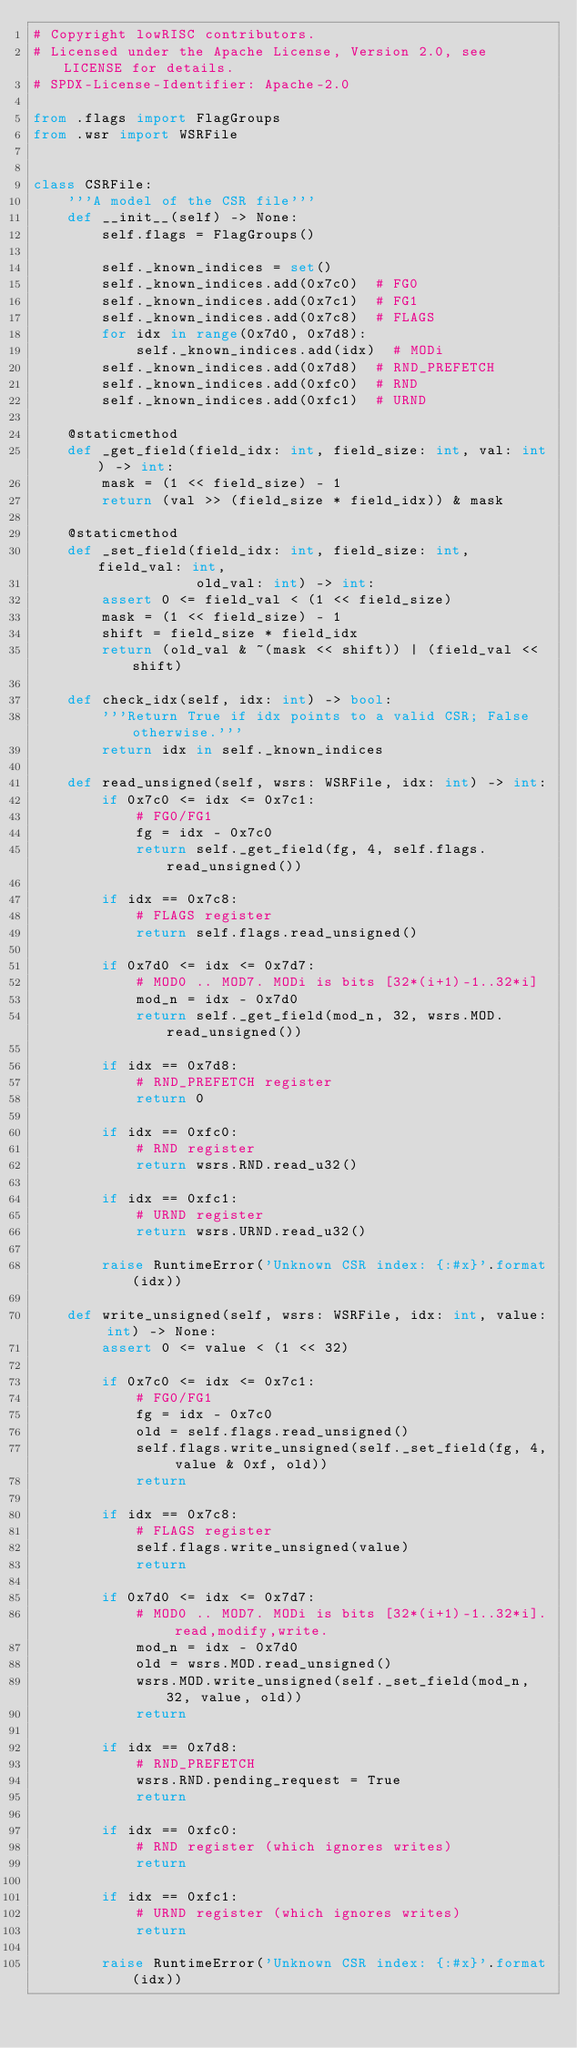Convert code to text. <code><loc_0><loc_0><loc_500><loc_500><_Python_># Copyright lowRISC contributors.
# Licensed under the Apache License, Version 2.0, see LICENSE for details.
# SPDX-License-Identifier: Apache-2.0

from .flags import FlagGroups
from .wsr import WSRFile


class CSRFile:
    '''A model of the CSR file'''
    def __init__(self) -> None:
        self.flags = FlagGroups()

        self._known_indices = set()
        self._known_indices.add(0x7c0)  # FG0
        self._known_indices.add(0x7c1)  # FG1
        self._known_indices.add(0x7c8)  # FLAGS
        for idx in range(0x7d0, 0x7d8):
            self._known_indices.add(idx)  # MODi
        self._known_indices.add(0x7d8)  # RND_PREFETCH
        self._known_indices.add(0xfc0)  # RND
        self._known_indices.add(0xfc1)  # URND

    @staticmethod
    def _get_field(field_idx: int, field_size: int, val: int) -> int:
        mask = (1 << field_size) - 1
        return (val >> (field_size * field_idx)) & mask

    @staticmethod
    def _set_field(field_idx: int, field_size: int, field_val: int,
                   old_val: int) -> int:
        assert 0 <= field_val < (1 << field_size)
        mask = (1 << field_size) - 1
        shift = field_size * field_idx
        return (old_val & ~(mask << shift)) | (field_val << shift)

    def check_idx(self, idx: int) -> bool:
        '''Return True if idx points to a valid CSR; False otherwise.'''
        return idx in self._known_indices

    def read_unsigned(self, wsrs: WSRFile, idx: int) -> int:
        if 0x7c0 <= idx <= 0x7c1:
            # FG0/FG1
            fg = idx - 0x7c0
            return self._get_field(fg, 4, self.flags.read_unsigned())

        if idx == 0x7c8:
            # FLAGS register
            return self.flags.read_unsigned()

        if 0x7d0 <= idx <= 0x7d7:
            # MOD0 .. MOD7. MODi is bits [32*(i+1)-1..32*i]
            mod_n = idx - 0x7d0
            return self._get_field(mod_n, 32, wsrs.MOD.read_unsigned())

        if idx == 0x7d8:
            # RND_PREFETCH register
            return 0

        if idx == 0xfc0:
            # RND register
            return wsrs.RND.read_u32()

        if idx == 0xfc1:
            # URND register
            return wsrs.URND.read_u32()

        raise RuntimeError('Unknown CSR index: {:#x}'.format(idx))

    def write_unsigned(self, wsrs: WSRFile, idx: int, value: int) -> None:
        assert 0 <= value < (1 << 32)

        if 0x7c0 <= idx <= 0x7c1:
            # FG0/FG1
            fg = idx - 0x7c0
            old = self.flags.read_unsigned()
            self.flags.write_unsigned(self._set_field(fg, 4, value & 0xf, old))
            return

        if idx == 0x7c8:
            # FLAGS register
            self.flags.write_unsigned(value)
            return

        if 0x7d0 <= idx <= 0x7d7:
            # MOD0 .. MOD7. MODi is bits [32*(i+1)-1..32*i]. read,modify,write.
            mod_n = idx - 0x7d0
            old = wsrs.MOD.read_unsigned()
            wsrs.MOD.write_unsigned(self._set_field(mod_n, 32, value, old))
            return

        if idx == 0x7d8:
            # RND_PREFETCH
            wsrs.RND.pending_request = True
            return

        if idx == 0xfc0:
            # RND register (which ignores writes)
            return

        if idx == 0xfc1:
            # URND register (which ignores writes)
            return

        raise RuntimeError('Unknown CSR index: {:#x}'.format(idx))
</code> 